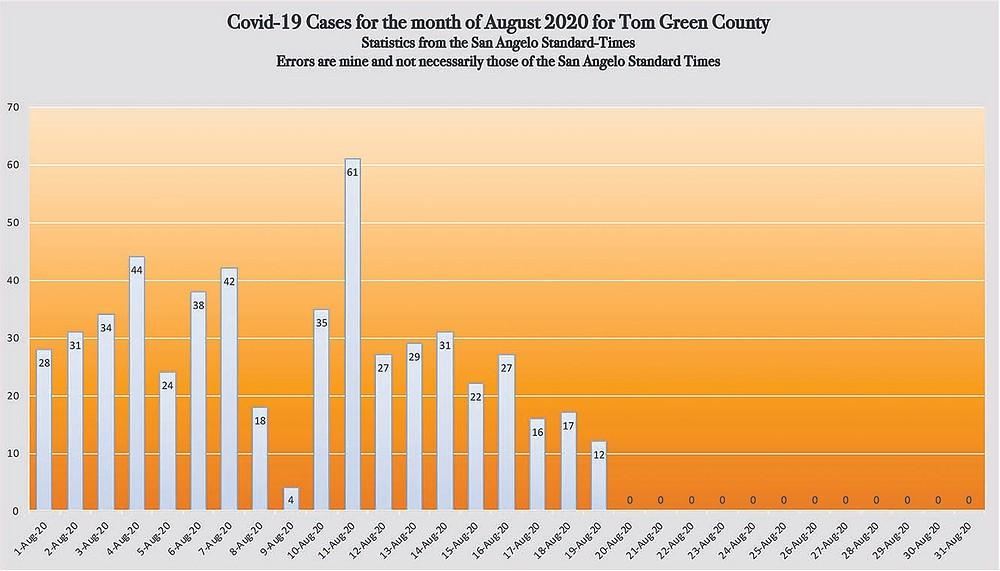List a handful of essential elements in this visual. How many cases are from 36 to 45 in total? The number of cases that is greater than 40 has exceeded that threshold for 3 days. In how many days are there fewer than 30 cases? 